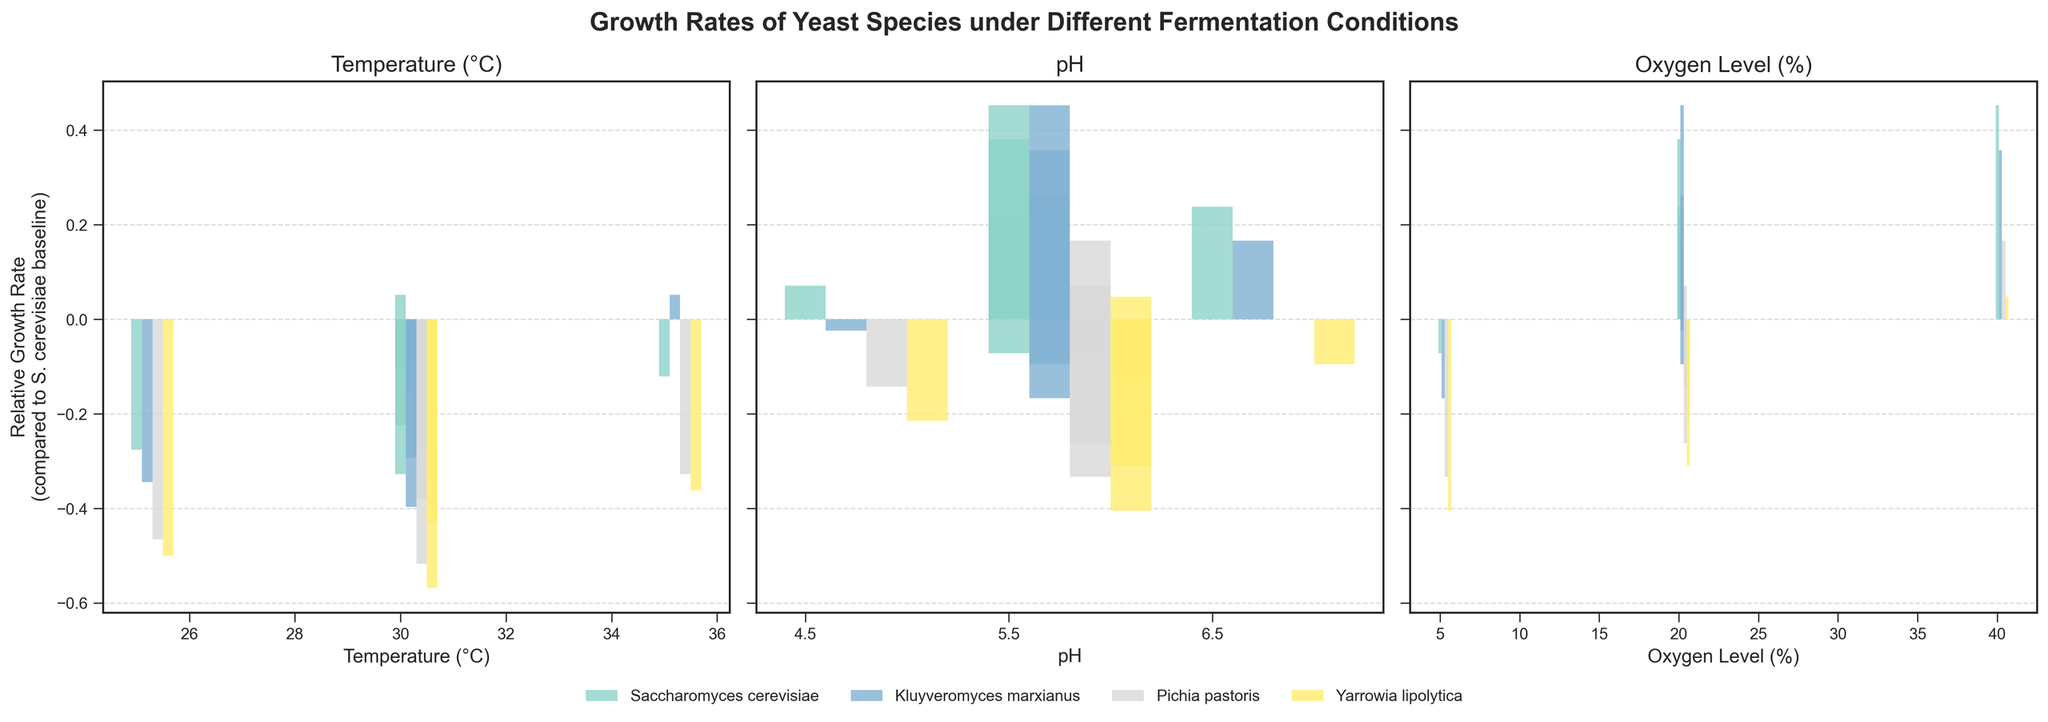What is the relative growth rate of Saccharomyces cerevisiae at 25°C compared to its baseline? Saccharomyces cerevisiae at 25°C has a growth rate of 0.42 g/L/h. The baseline for Saccharomyces cerevisiae is 0.58 g/L/h (at 30°C, pH 5.5, 20% O2). The relative growth rate is (0.42/0.58) - 1.
Answer: -0.276 Which species shows the highest relative growth rate at 35°C? The bar corresponding to Kluyveromyces marxianus at 35°C is taller than for other species.
Answer: Kluyveromyces marxianus How does the growth rate of Pichia pastoris at pH 4.5 compare to that at pH 6.5? Pichia pastoris has growth rates of 0.36 g/L/h and 0.42 g/L/h at pH 4.5 and pH 6.5, respectively. Comparing these, (0.36 - 0.42) = -0.06 or 0.36/0.42 - 1 = -0.142857.
Answer: -0.06 or -0.142857 How many species show a positive relative growth rate under 40% oxygen conditions? By examining the bars for 40% oxygen across all species, we see that Saccharomyces cerevisiae, Kluyveromyces marxianus, and Pichia pastoris have positive bars.
Answer: 3 Between Kluyveromyces marxianus and Yarrowia lipolytica, which species shows a larger relative increase in growth rate when oxygen levels are raised from 5% to 40%? For Kluyveromyces marxianus: (0.57/0.35) - 1 = 0.628. For Yarrowia lipolytica: (0.44/0.25) - 1 = 0.76. Yarrowia lipolytica shows a larger relative increase.
Answer: Yarrowia lipolytica Describe the visual differences in the bar heights for Saccharomyces cerevisiae and Kluyveromyces marxianus across temperature conditions. The bars for Kluyveromyces marxianus at 25°C and 35°C are generally higher than those for Saccharomyces cerevisiae. However, at 30°C, Saccharomyces cerevisiae has a higher bar.
Answer: At 25°C and 35°C: Kluyveromyces marxianus is higher; at 30°C: Saccharomyces cerevisiae is higher What is the percent increase in growth rate of Saccharomyces cerevisiae when increasing the oxygen level from 5% to 40%? The growth rates for Saccharomyces cerevisiae at 5% and 40% oxygen levels are 0.39 and 0.61 g/L/h, respectively. The percent increase is ((0.61 - 0.39) / 0.39) * 100%.
Answer: 56.41% Compare the relative growth rates of Yarrowia lipolytica and Pichia pastoris at 25°C. Which one grows better and by how much? The growth rate of Yarrowia lipolytica at 25°C is 0.29 g/L/h, and for Pichia pastoris, it is 0.31 g/L/h. The relative difference: (0.31 - 0.29) g/L/h = 0.02 g/L/h.
Answer: Pichia pastoris by 0.02 g/L/h 